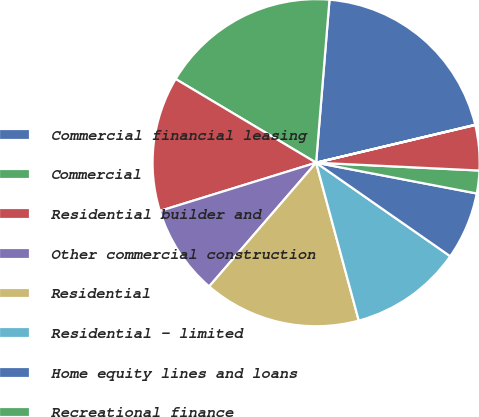Convert chart to OTSL. <chart><loc_0><loc_0><loc_500><loc_500><pie_chart><fcel>Commercial financial leasing<fcel>Commercial<fcel>Residential builder and<fcel>Other commercial construction<fcel>Residential<fcel>Residential - limited<fcel>Home equity lines and loans<fcel>Recreational finance<fcel>Automobile<fcel>Other<nl><fcel>19.97%<fcel>17.75%<fcel>13.32%<fcel>8.89%<fcel>15.54%<fcel>11.11%<fcel>6.68%<fcel>2.25%<fcel>4.46%<fcel>0.03%<nl></chart> 